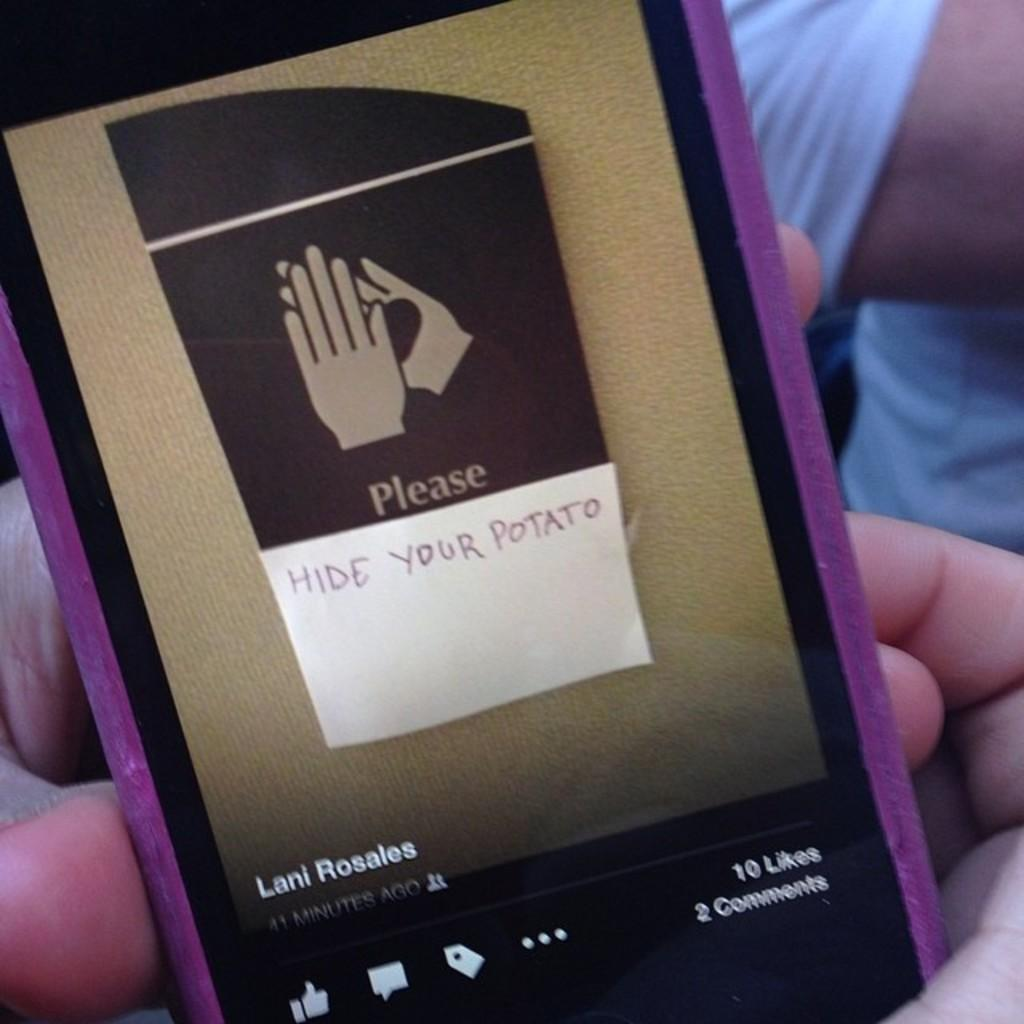What is being held by the hands in the image? There is a device being held by the hands in the image. What can be seen on the screen of the device? The device has text on its screen. Can you describe the person visible on the backside of the device? There is a person visible on the backside of the device. How many snakes are slithering around the device in the image? There are no snakes present in the image. What type of crib is visible in the image? There is no crib present in the image. 